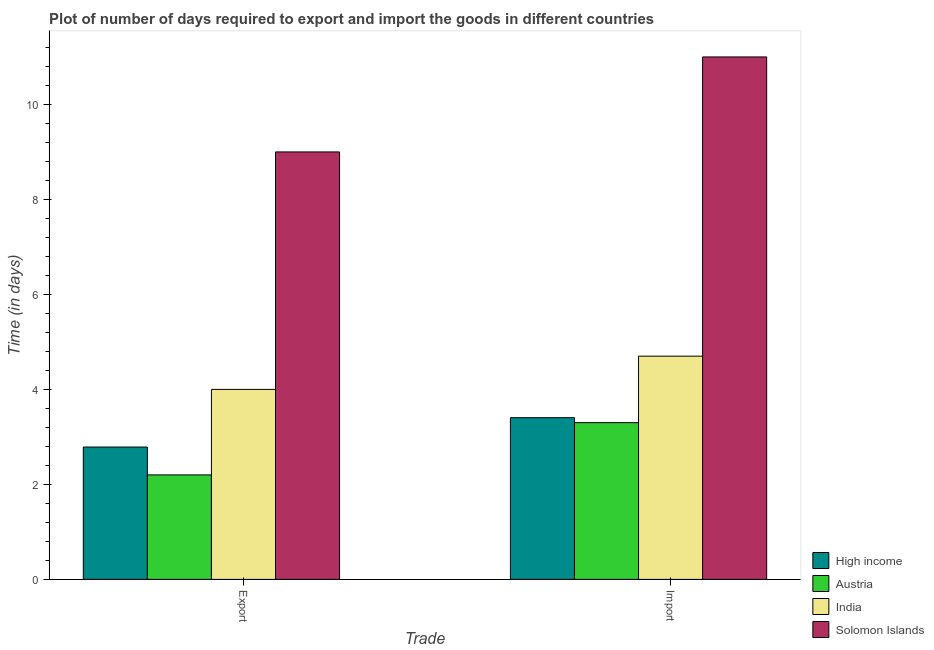Are the number of bars on each tick of the X-axis equal?
Make the answer very short. Yes. How many bars are there on the 1st tick from the left?
Provide a short and direct response. 4. How many bars are there on the 2nd tick from the right?
Your answer should be compact. 4. What is the label of the 1st group of bars from the left?
Provide a short and direct response. Export. Across all countries, what is the minimum time required to import?
Make the answer very short. 3.3. In which country was the time required to export maximum?
Your answer should be compact. Solomon Islands. In which country was the time required to export minimum?
Ensure brevity in your answer.  Austria. What is the total time required to import in the graph?
Offer a terse response. 22.4. What is the difference between the time required to import in High income and that in Austria?
Offer a very short reply. 0.1. What is the difference between the time required to import in High income and the time required to export in Solomon Islands?
Provide a short and direct response. -5.6. What is the average time required to export per country?
Give a very brief answer. 4.5. What is the ratio of the time required to export in Austria to that in Solomon Islands?
Offer a terse response. 0.24. In how many countries, is the time required to export greater than the average time required to export taken over all countries?
Your answer should be compact. 1. What does the 4th bar from the left in Export represents?
Keep it short and to the point. Solomon Islands. Are all the bars in the graph horizontal?
Offer a very short reply. No. How many countries are there in the graph?
Ensure brevity in your answer.  4. What is the difference between two consecutive major ticks on the Y-axis?
Your response must be concise. 2. Does the graph contain any zero values?
Keep it short and to the point. No. Does the graph contain grids?
Your answer should be compact. No. Where does the legend appear in the graph?
Make the answer very short. Bottom right. How are the legend labels stacked?
Offer a very short reply. Vertical. What is the title of the graph?
Provide a short and direct response. Plot of number of days required to export and import the goods in different countries. Does "Italy" appear as one of the legend labels in the graph?
Provide a succinct answer. No. What is the label or title of the X-axis?
Give a very brief answer. Trade. What is the label or title of the Y-axis?
Give a very brief answer. Time (in days). What is the Time (in days) of High income in Export?
Your answer should be very brief. 2.79. What is the Time (in days) in India in Export?
Keep it short and to the point. 4. What is the Time (in days) in Solomon Islands in Export?
Your response must be concise. 9. What is the Time (in days) in High income in Import?
Ensure brevity in your answer.  3.4. What is the Time (in days) of Austria in Import?
Provide a short and direct response. 3.3. What is the Time (in days) in India in Import?
Offer a very short reply. 4.7. What is the Time (in days) of Solomon Islands in Import?
Offer a very short reply. 11. Across all Trade, what is the maximum Time (in days) in High income?
Give a very brief answer. 3.4. Across all Trade, what is the maximum Time (in days) in Austria?
Provide a short and direct response. 3.3. Across all Trade, what is the maximum Time (in days) of India?
Provide a succinct answer. 4.7. Across all Trade, what is the maximum Time (in days) of Solomon Islands?
Offer a very short reply. 11. Across all Trade, what is the minimum Time (in days) of High income?
Offer a very short reply. 2.79. Across all Trade, what is the minimum Time (in days) in Austria?
Keep it short and to the point. 2.2. Across all Trade, what is the minimum Time (in days) of India?
Your answer should be compact. 4. Across all Trade, what is the minimum Time (in days) in Solomon Islands?
Offer a terse response. 9. What is the total Time (in days) in High income in the graph?
Offer a very short reply. 6.19. What is the total Time (in days) of Austria in the graph?
Provide a short and direct response. 5.5. What is the total Time (in days) of Solomon Islands in the graph?
Provide a short and direct response. 20. What is the difference between the Time (in days) of High income in Export and that in Import?
Provide a short and direct response. -0.62. What is the difference between the Time (in days) of Austria in Export and that in Import?
Your answer should be very brief. -1.1. What is the difference between the Time (in days) in High income in Export and the Time (in days) in Austria in Import?
Ensure brevity in your answer.  -0.51. What is the difference between the Time (in days) of High income in Export and the Time (in days) of India in Import?
Keep it short and to the point. -1.91. What is the difference between the Time (in days) of High income in Export and the Time (in days) of Solomon Islands in Import?
Make the answer very short. -8.21. What is the difference between the Time (in days) in India in Export and the Time (in days) in Solomon Islands in Import?
Your answer should be compact. -7. What is the average Time (in days) in High income per Trade?
Your response must be concise. 3.1. What is the average Time (in days) of Austria per Trade?
Ensure brevity in your answer.  2.75. What is the average Time (in days) in India per Trade?
Keep it short and to the point. 4.35. What is the difference between the Time (in days) in High income and Time (in days) in Austria in Export?
Provide a succinct answer. 0.59. What is the difference between the Time (in days) in High income and Time (in days) in India in Export?
Offer a terse response. -1.21. What is the difference between the Time (in days) of High income and Time (in days) of Solomon Islands in Export?
Make the answer very short. -6.21. What is the difference between the Time (in days) of India and Time (in days) of Solomon Islands in Export?
Provide a succinct answer. -5. What is the difference between the Time (in days) of High income and Time (in days) of Austria in Import?
Your response must be concise. 0.1. What is the difference between the Time (in days) of High income and Time (in days) of India in Import?
Ensure brevity in your answer.  -1.3. What is the difference between the Time (in days) in High income and Time (in days) in Solomon Islands in Import?
Your response must be concise. -7.6. What is the ratio of the Time (in days) in High income in Export to that in Import?
Your answer should be very brief. 0.82. What is the ratio of the Time (in days) in Austria in Export to that in Import?
Your answer should be compact. 0.67. What is the ratio of the Time (in days) in India in Export to that in Import?
Your answer should be compact. 0.85. What is the ratio of the Time (in days) of Solomon Islands in Export to that in Import?
Ensure brevity in your answer.  0.82. What is the difference between the highest and the second highest Time (in days) of High income?
Give a very brief answer. 0.62. What is the difference between the highest and the second highest Time (in days) in Austria?
Your response must be concise. 1.1. What is the difference between the highest and the second highest Time (in days) of India?
Your answer should be compact. 0.7. What is the difference between the highest and the lowest Time (in days) in High income?
Your answer should be very brief. 0.62. 